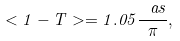Convert formula to latex. <formula><loc_0><loc_0><loc_500><loc_500>< 1 - T > = 1 . 0 5 \frac { \ a s } { \pi } ,</formula> 